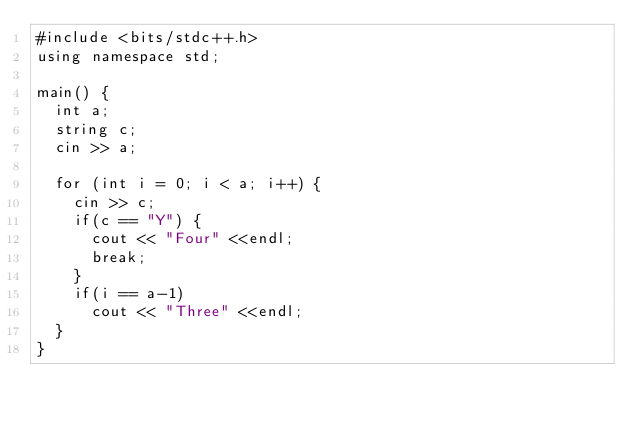Convert code to text. <code><loc_0><loc_0><loc_500><loc_500><_C++_>#include <bits/stdc++.h>
using namespace std;

main() {
  int a;
  string c;
  cin >> a;
  
  for (int i = 0; i < a; i++) {
    cin >> c;
    if(c == "Y") {
      cout << "Four" <<endl;
      break;
    }
    if(i == a-1)
      cout << "Three" <<endl;
  }
}
     </code> 